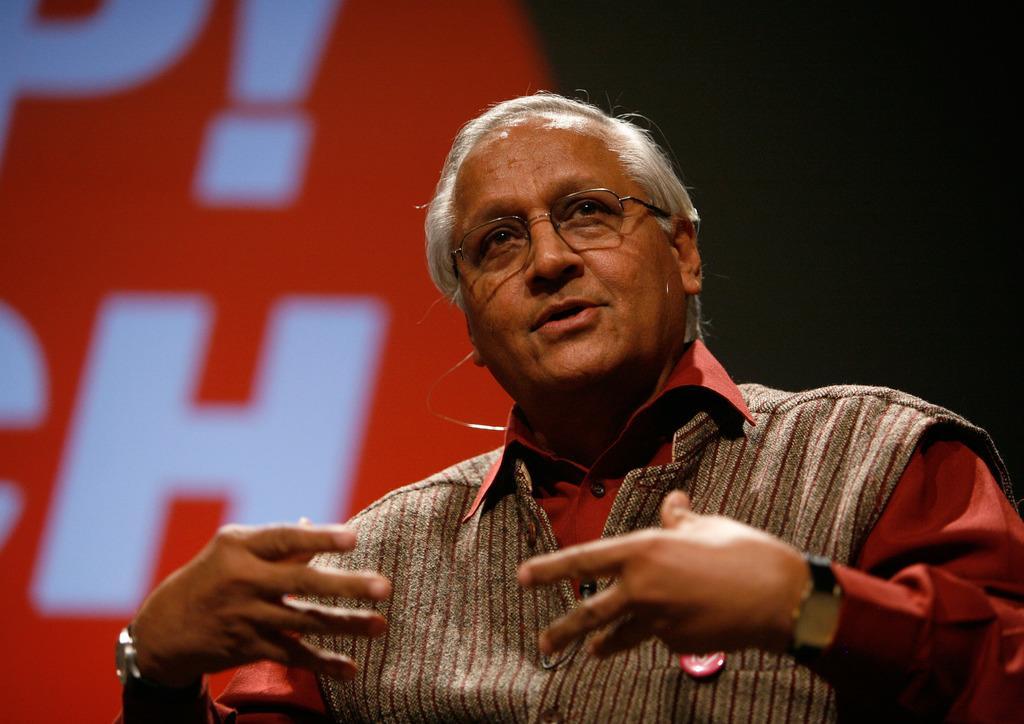Can you describe this image briefly? In this image, I can see a person, poster and a dark color. This image is taken, maybe during night. 